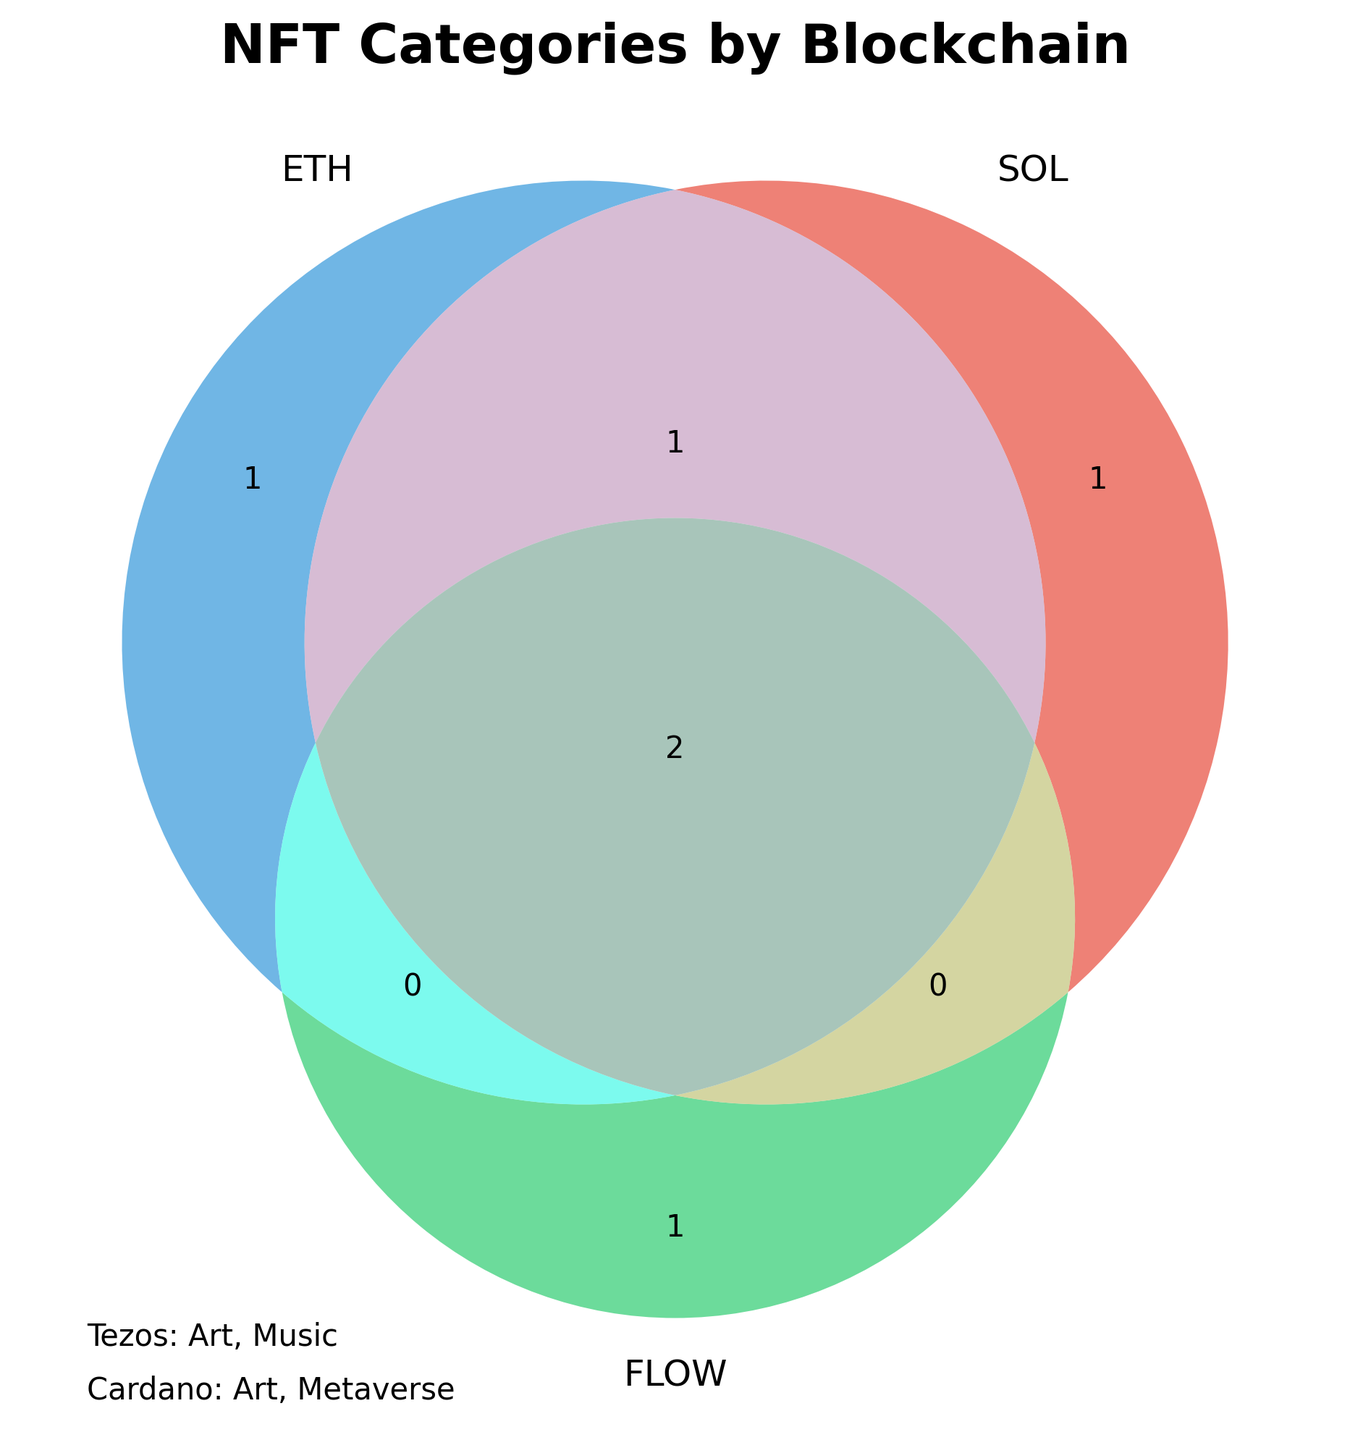What is the title of the figure? The figure prominently displays the title at the top in bold and large font. The title reads 'NFT Categories by Blockchain', which succinctly summarizes the content of the diagram.
Answer: NFT Categories by Blockchain Which blockchain has the most NFT categories in common with Ethereum? By observing the overlaps in the Venn diagram, Solana shares the most categories with Ethereum as they overlap in three categories: Art, Collectibles, and Gaming. Flow only shares one category with Ethereum.
Answer: Solana How many NFT categories are unique to Flow? The unique region for Flow in the Venn diagram only contains one category, which is Sports.
Answer: 1 Which blockchain includes 'Music' as an NFT category? From the text annotations outside the Venn diagram, it is clear that both Ethereum and Tezos have 'Music' listed as an NFT category.
Answer: Ethereum and Tezos Which blockchains have 'Metaverse' as an NFT category? 'Metaverse' appears within the Venn diagram under Solana and also outside in the text annotation under Cardano.
Answer: Solana and Cardano Which categories are common across all three blockchains in the Venn diagram? By looking at the intersection of all three parts of the Venn diagram, it can be seen that there is no category that appears in all three blockchains (Ethereum, Solana, and Flow).
Answer: None How many total NFT categories are shown in the Venn diagram? The Venn diagram and its annotations show a total of 6 unique categories within the Venn itself (Art, Collectibles, Music, Gaming, Sports, Metaverse), with no category appearing in all three blockchains.
Answer: 6 Which blockchain has the most diverse range of NFT categories? By counting the unique NFT categories within each blockchain section in the Venn diagram, Ethereum has 4 categories, Solana has 4 categories, and Flow has 3 categories. Both Ethereum and Solana have the most diverse range of categories.
Answer: Ethereum and Solana 